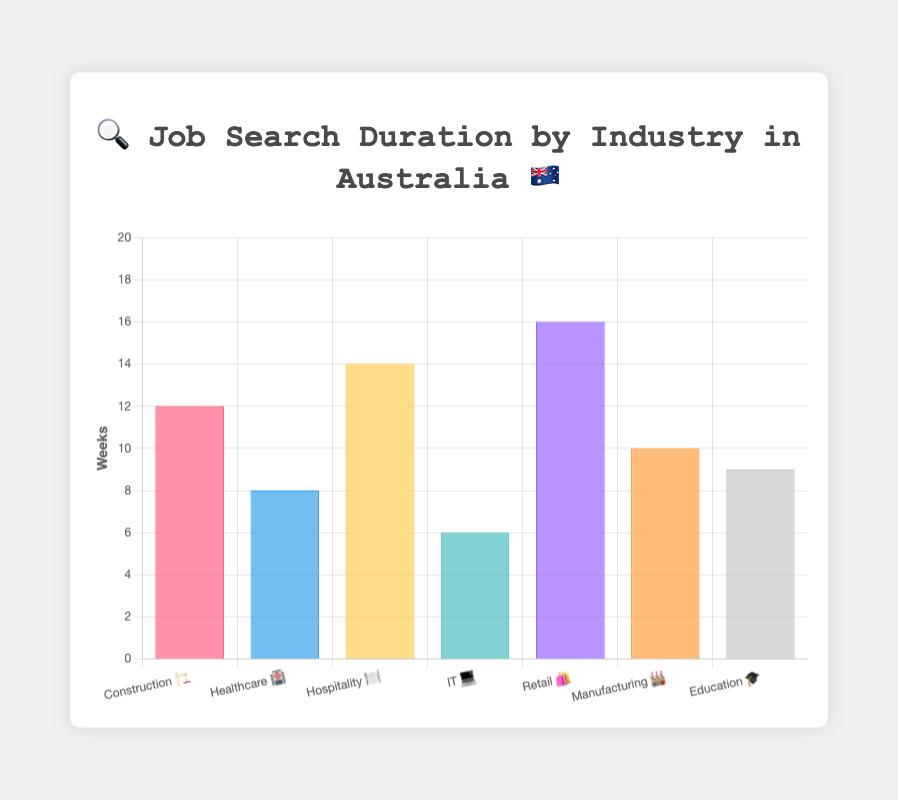Which industry has the longest average job search duration based on the figure? The tallest bar represents the industry with the longest average job search duration. In the figure, it’s the bar for Retail 🛍️.
Answer: Retail 🛍️ Which industry has the shortest average job search duration? The shortest bar represents the industry with the shortest average job search duration. In the figure, it’s the bar for IT 💻.
Answer: IT 💻 How many weeks does it take on average for someone in Hospitality 🍽️ to find a job? Find the bar labeled Hospitality 🍽️ and check its height. The height corresponds to 14 weeks.
Answer: 14 weeks What is the difference in average job search duration between Construction 🏗️ and Healthcare 🏥? Look at the bars for Construction 🏗️ and Healthcare 🏥 and subtract the height of the Healthcare bar from the Construction bar. 12 weeks (Construction) - 8 weeks (Healthcare) = 4 weeks.
Answer: 4 weeks Which two industries have the same color background in the chart? Each bar has a unique color, so no two industries share the same background color in this chart.
Answer: None What is the combined average job search duration for IT 💻 and Manufacturing 🏭? Add the average job search duration for IT 💻 (6 weeks) and Manufacturing 🏭 (10 weeks). 6 + 10 = 16 weeks.
Answer: 16 weeks How does the average job search duration for Education 🎓 compare to Manufacturing 🏭? Compare the heights of the bars for Education 🎓 and Manufacturing 🏭. The Education 🎓 bar is slightly lower than the Manufacturing 🏭 bar, indicating a shorter duration.
Answer: Shorter What’s the median average job search duration across all industries represented? List the durations: 6 (IT), 8 (Healthcare), 9 (Education), 10 (Manufacturing), 12 (Construction), 14 (Hospitality), 16 (Retail). The median value is the middle value in an ordered list, which is 10.
Answer: 10 weeks Which industry has a job search duration closest to 10 weeks? Find the industry whose bar is closest to the 10-week mark. For Manufacturing 🏭, the job search duration is exactly 10 weeks.
Answer: Manufacturing 🏭 